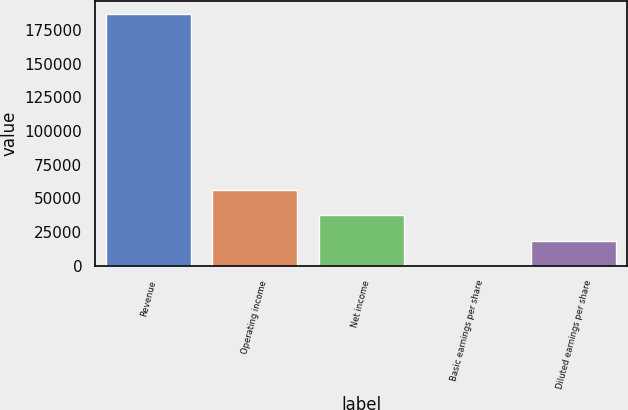Convert chart. <chart><loc_0><loc_0><loc_500><loc_500><bar_chart><fcel>Revenue<fcel>Operating income<fcel>Net income<fcel>Basic earnings per share<fcel>Diluted earnings per share<nl><fcel>187015<fcel>56104.7<fcel>37403.2<fcel>0.26<fcel>18701.7<nl></chart> 